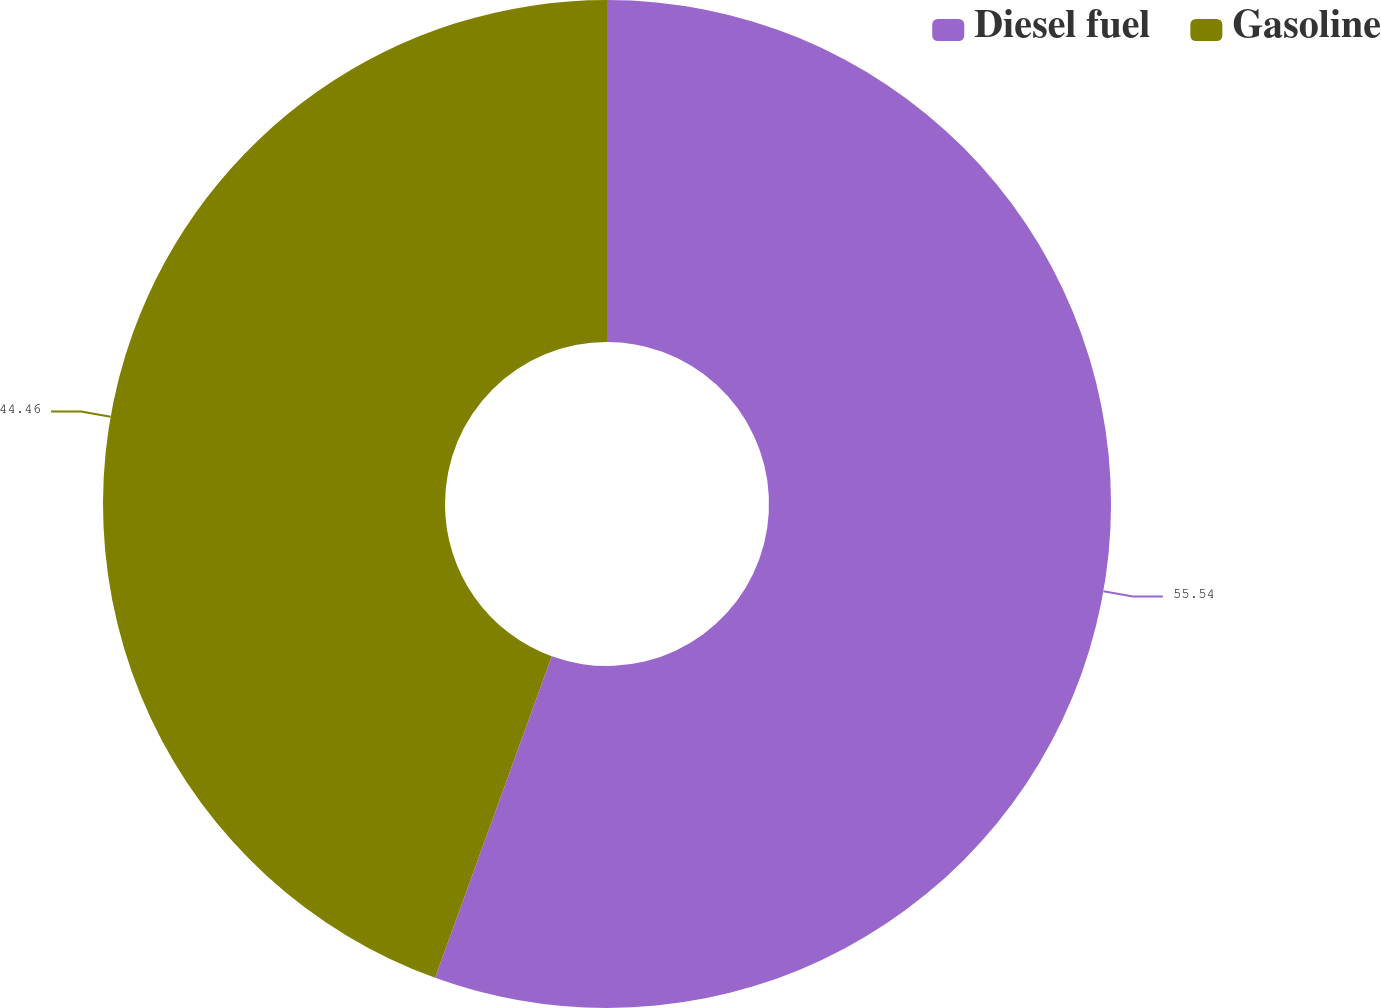Convert chart. <chart><loc_0><loc_0><loc_500><loc_500><pie_chart><fcel>Diesel fuel<fcel>Gasoline<nl><fcel>55.54%<fcel>44.46%<nl></chart> 